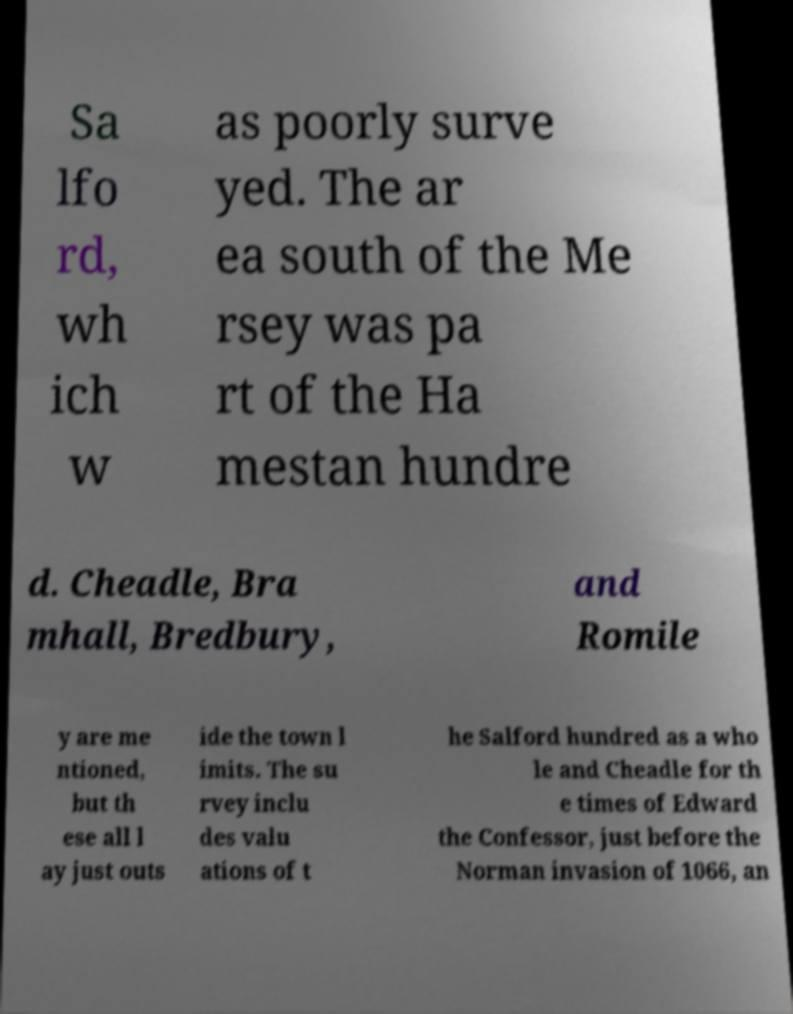Can you accurately transcribe the text from the provided image for me? Sa lfo rd, wh ich w as poorly surve yed. The ar ea south of the Me rsey was pa rt of the Ha mestan hundre d. Cheadle, Bra mhall, Bredbury, and Romile y are me ntioned, but th ese all l ay just outs ide the town l imits. The su rvey inclu des valu ations of t he Salford hundred as a who le and Cheadle for th e times of Edward the Confessor, just before the Norman invasion of 1066, an 